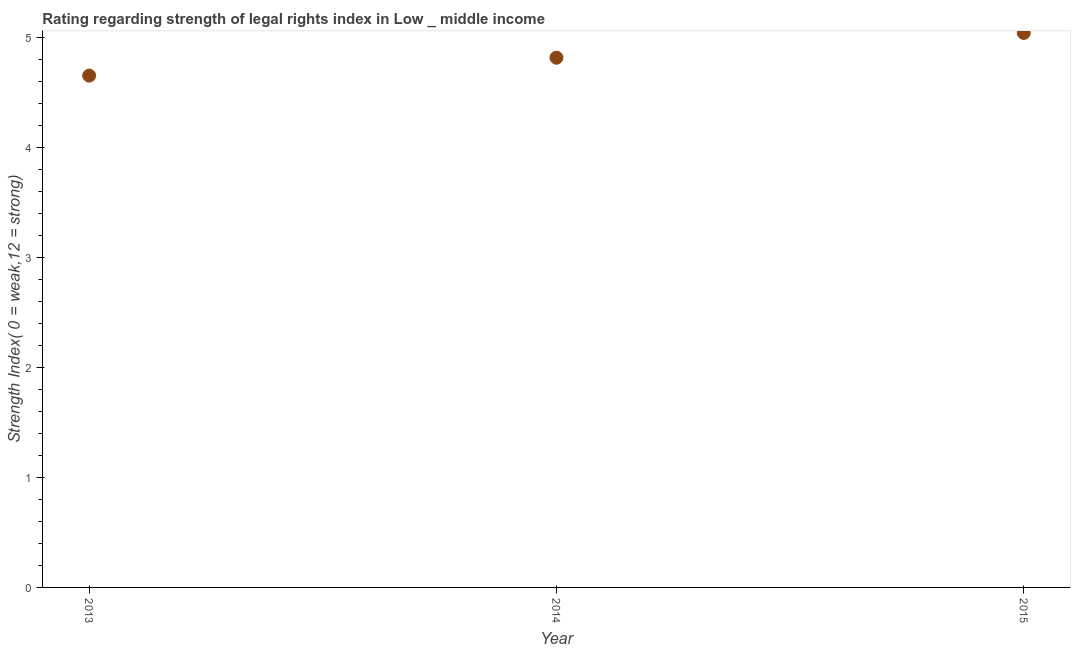What is the strength of legal rights index in 2014?
Make the answer very short. 4.81. Across all years, what is the maximum strength of legal rights index?
Ensure brevity in your answer.  5.04. Across all years, what is the minimum strength of legal rights index?
Ensure brevity in your answer.  4.65. In which year was the strength of legal rights index maximum?
Offer a very short reply. 2015. What is the sum of the strength of legal rights index?
Your response must be concise. 14.5. What is the difference between the strength of legal rights index in 2013 and 2014?
Give a very brief answer. -0.16. What is the average strength of legal rights index per year?
Make the answer very short. 4.83. What is the median strength of legal rights index?
Your response must be concise. 4.81. What is the ratio of the strength of legal rights index in 2013 to that in 2015?
Your response must be concise. 0.92. Is the difference between the strength of legal rights index in 2014 and 2015 greater than the difference between any two years?
Ensure brevity in your answer.  No. What is the difference between the highest and the second highest strength of legal rights index?
Make the answer very short. 0.22. Is the sum of the strength of legal rights index in 2014 and 2015 greater than the maximum strength of legal rights index across all years?
Offer a very short reply. Yes. What is the difference between the highest and the lowest strength of legal rights index?
Ensure brevity in your answer.  0.39. In how many years, is the strength of legal rights index greater than the average strength of legal rights index taken over all years?
Provide a short and direct response. 1. Does the strength of legal rights index monotonically increase over the years?
Give a very brief answer. Yes. How many dotlines are there?
Give a very brief answer. 1. What is the difference between two consecutive major ticks on the Y-axis?
Offer a terse response. 1. Are the values on the major ticks of Y-axis written in scientific E-notation?
Your answer should be very brief. No. Does the graph contain any zero values?
Your response must be concise. No. What is the title of the graph?
Offer a terse response. Rating regarding strength of legal rights index in Low _ middle income. What is the label or title of the Y-axis?
Ensure brevity in your answer.  Strength Index( 0 = weak,12 = strong). What is the Strength Index( 0 = weak,12 = strong) in 2013?
Keep it short and to the point. 4.65. What is the Strength Index( 0 = weak,12 = strong) in 2014?
Give a very brief answer. 4.81. What is the Strength Index( 0 = weak,12 = strong) in 2015?
Your answer should be compact. 5.04. What is the difference between the Strength Index( 0 = weak,12 = strong) in 2013 and 2014?
Make the answer very short. -0.16. What is the difference between the Strength Index( 0 = weak,12 = strong) in 2013 and 2015?
Provide a succinct answer. -0.39. What is the difference between the Strength Index( 0 = weak,12 = strong) in 2014 and 2015?
Offer a terse response. -0.22. What is the ratio of the Strength Index( 0 = weak,12 = strong) in 2013 to that in 2015?
Your answer should be very brief. 0.92. What is the ratio of the Strength Index( 0 = weak,12 = strong) in 2014 to that in 2015?
Provide a succinct answer. 0.95. 